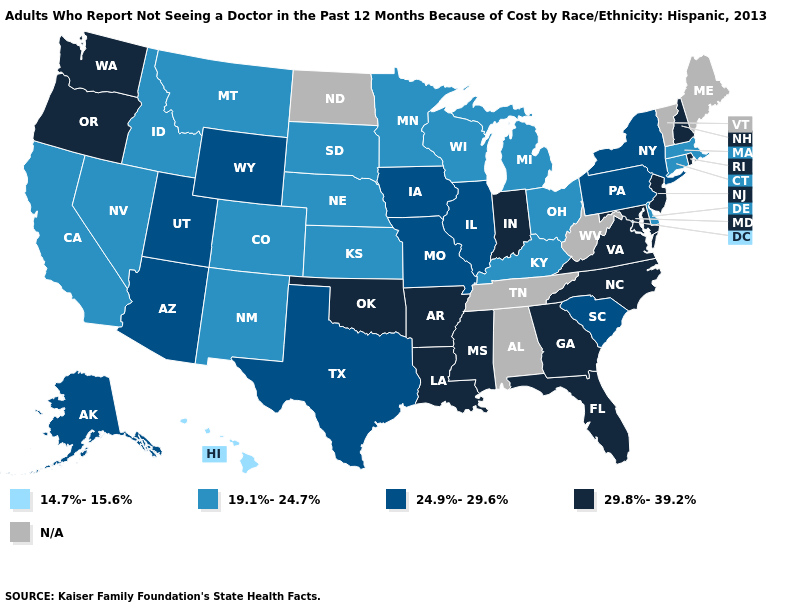What is the value of Arkansas?
Concise answer only. 29.8%-39.2%. Does the first symbol in the legend represent the smallest category?
Write a very short answer. Yes. How many symbols are there in the legend?
Concise answer only. 5. What is the value of Wyoming?
Write a very short answer. 24.9%-29.6%. Does Indiana have the lowest value in the MidWest?
Write a very short answer. No. Name the states that have a value in the range N/A?
Answer briefly. Alabama, Maine, North Dakota, Tennessee, Vermont, West Virginia. What is the highest value in the Northeast ?
Answer briefly. 29.8%-39.2%. Which states have the highest value in the USA?
Answer briefly. Arkansas, Florida, Georgia, Indiana, Louisiana, Maryland, Mississippi, New Hampshire, New Jersey, North Carolina, Oklahoma, Oregon, Rhode Island, Virginia, Washington. What is the lowest value in the USA?
Quick response, please. 14.7%-15.6%. What is the lowest value in the USA?
Write a very short answer. 14.7%-15.6%. Among the states that border Washington , which have the highest value?
Short answer required. Oregon. Name the states that have a value in the range 14.7%-15.6%?
Short answer required. Hawaii. 